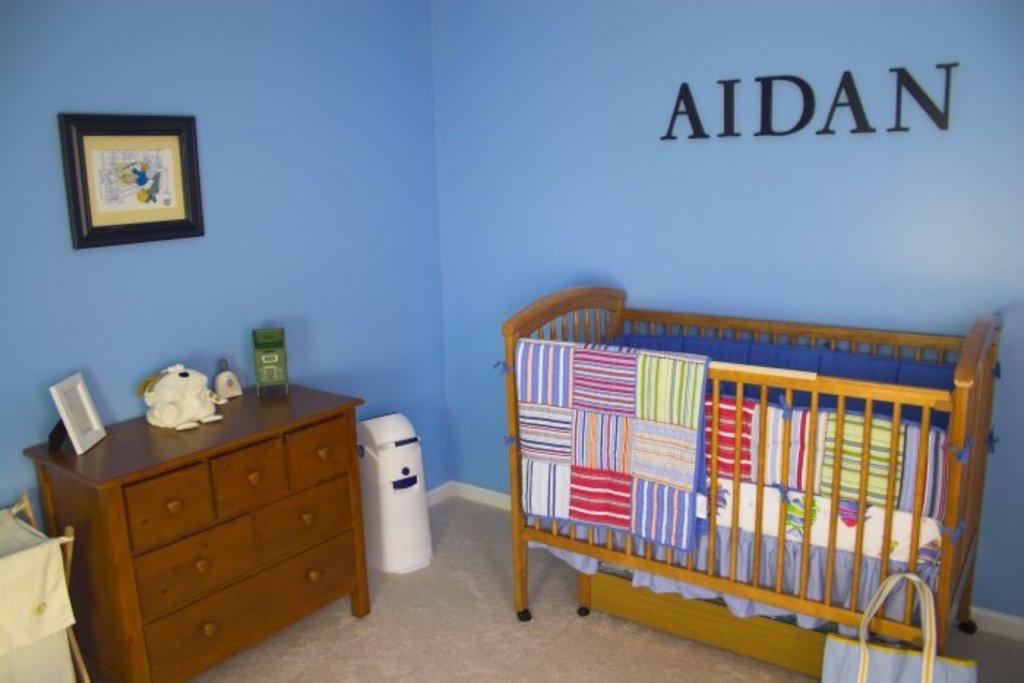Can you describe this image briefly? The picture is clicked inside a room. To the right corner of the image there is a cradle and beside it there is a bag. To the left corner of the image there is a table with chest of drawers. On it there is a bottle, a frame and a sculpture. Beside to it there is a machine. In the background there is wall. There is a picture frame hanging on the wall and there is text "Aiden" on it. 